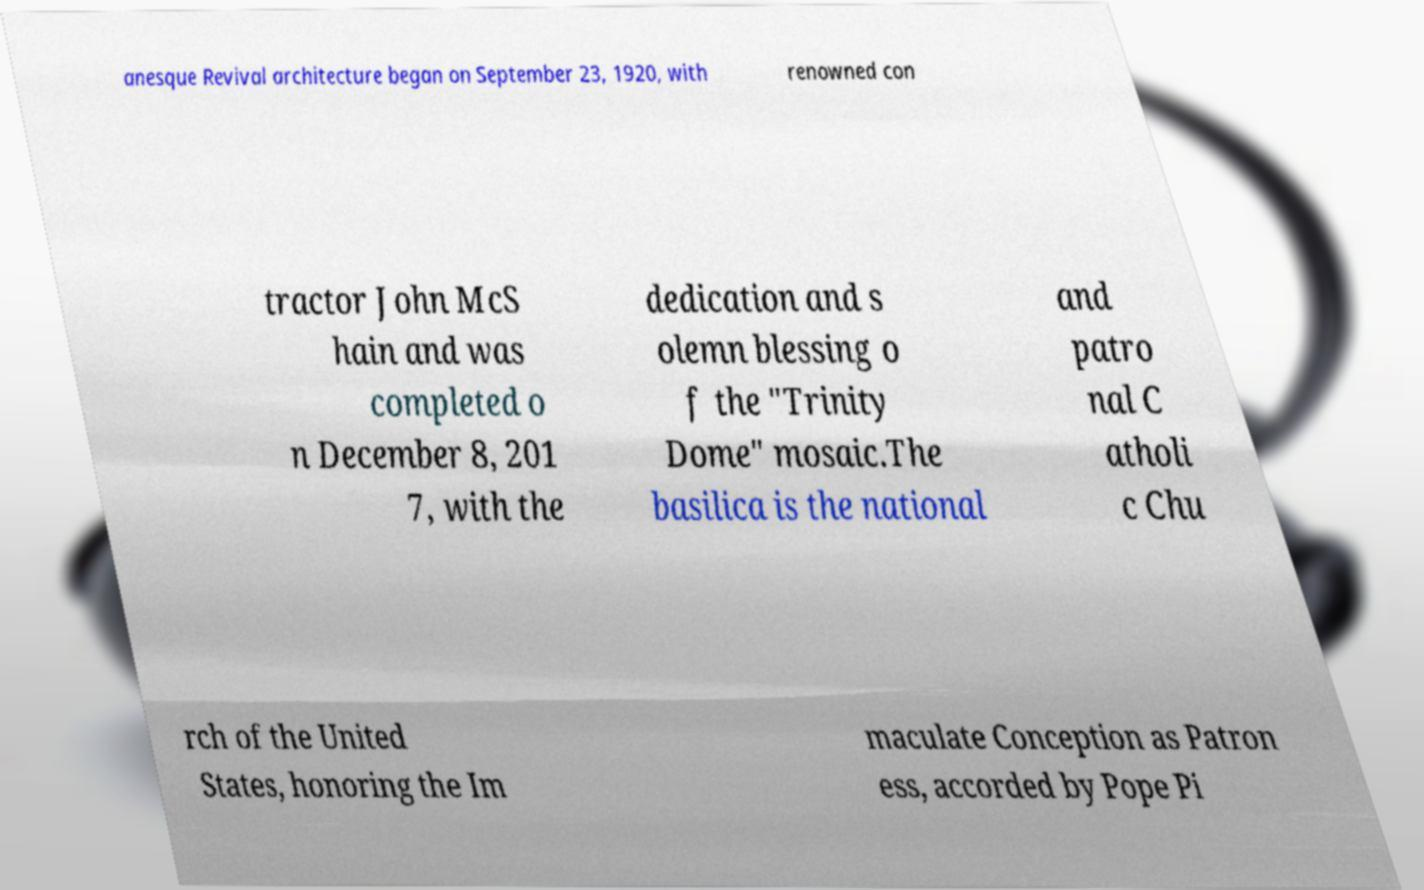Could you extract and type out the text from this image? anesque Revival architecture began on September 23, 1920, with renowned con tractor John McS hain and was completed o n December 8, 201 7, with the dedication and s olemn blessing o f the "Trinity Dome" mosaic.The basilica is the national and patro nal C atholi c Chu rch of the United States, honoring the Im maculate Conception as Patron ess, accorded by Pope Pi 